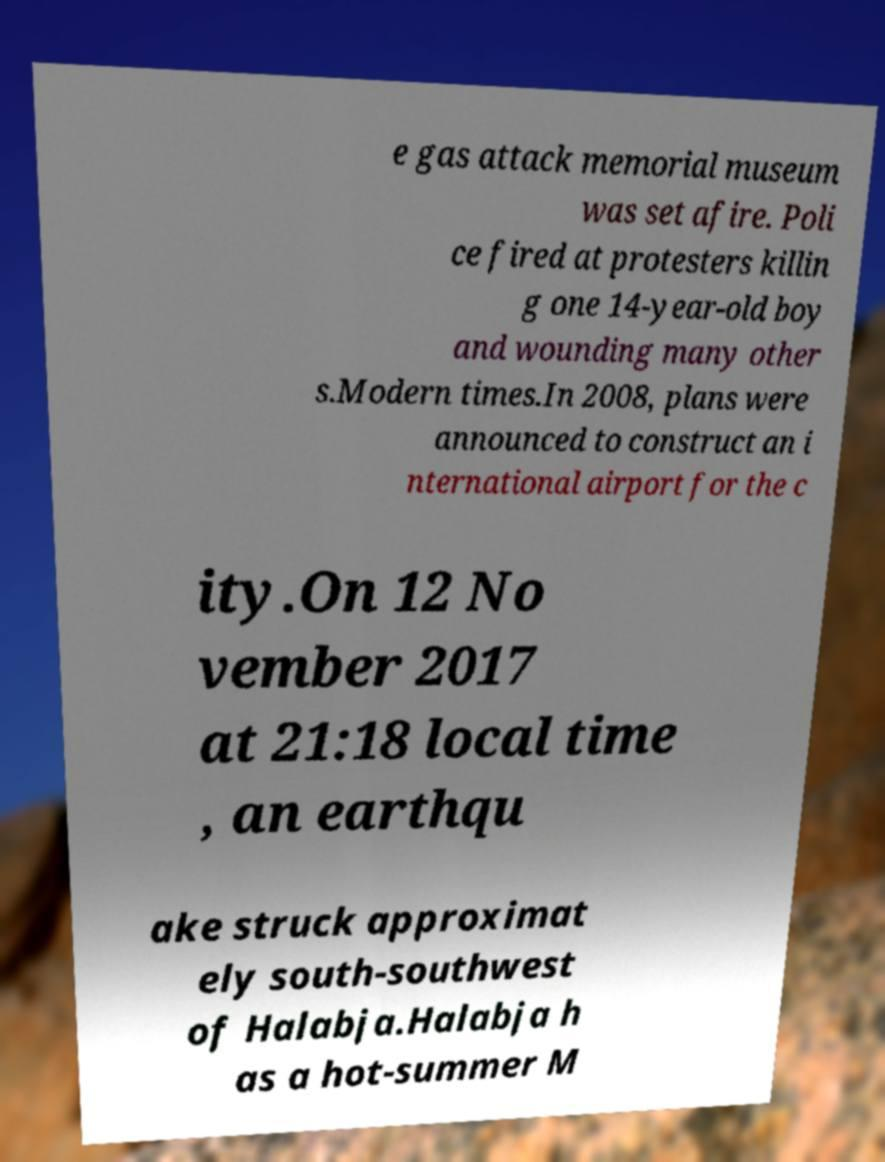What messages or text are displayed in this image? I need them in a readable, typed format. e gas attack memorial museum was set afire. Poli ce fired at protesters killin g one 14-year-old boy and wounding many other s.Modern times.In 2008, plans were announced to construct an i nternational airport for the c ity.On 12 No vember 2017 at 21:18 local time , an earthqu ake struck approximat ely south-southwest of Halabja.Halabja h as a hot-summer M 